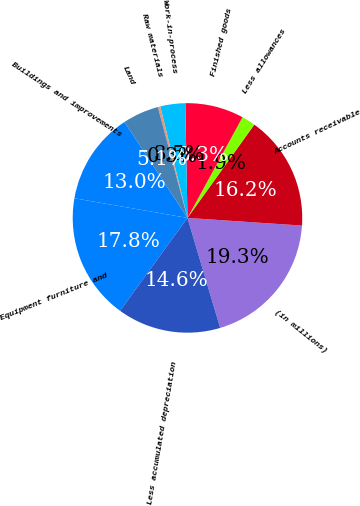<chart> <loc_0><loc_0><loc_500><loc_500><pie_chart><fcel>(in millions)<fcel>Accounts receivable<fcel>Less allowances<fcel>Finished goods<fcel>Work-in-process<fcel>Raw materials<fcel>Land<fcel>Buildings and improvements<fcel>Equipment furniture and<fcel>Less accumulated depreciation<nl><fcel>19.34%<fcel>16.17%<fcel>1.93%<fcel>8.26%<fcel>3.51%<fcel>0.35%<fcel>5.09%<fcel>13.01%<fcel>17.75%<fcel>14.59%<nl></chart> 